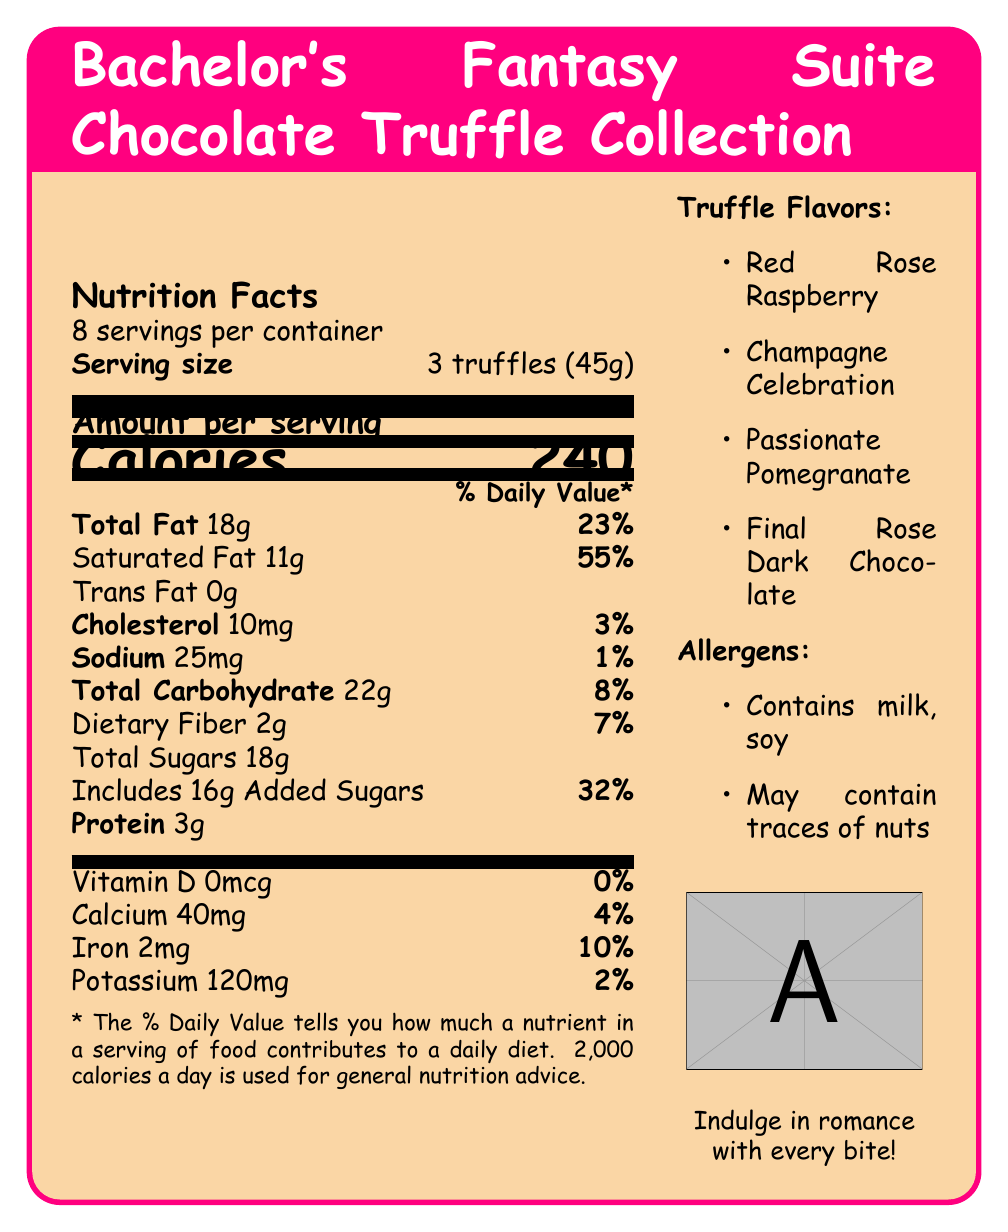which truffle flavor is not listed in the document? A. Red Rose Raspberry B. Champagne Celebration C. Sweet Strawberry D. Final Rose Dark Chocolate The truffle flavors listed are Red Rose Raspberry, Champagne Celebration, Passionate Pomegranate, and Final Rose Dark Chocolate. Sweet Strawberry is not listed.
Answer: C how many truffles make up one serving? According to the document, one serving size is 3 truffles (45g).
Answer: 3 truffles what are the total calories per serving? The document states that there are 240 calories per serving.
Answer: 240 calories which nutrient has the highest percentage daily value per serving? The \% Daily Value for Saturated Fat is 55\%, which is the highest among the listed nutrients.
Answer: Saturated Fat how many servings are in the container? The document specifies that there are 8 servings per container.
Answer: 8 servings which of the following is not an allergen mentioned in the document? A. Milk B. Soy C. Gluten D. Nuts The document lists milk and soy as allergens and mentions that it may contain traces of nuts. Gluten is not mentioned.
Answer: C does the document suggest pairing the truffles with Ben Higgins' Generous Coffee? The document includes Ben Higgins' Generous Coffee as one of the Bachelor-themed pairings.
Answer: Yes which vitamin or mineral has a daily value percentage of 0\%? The document lists Vitamin D with a daily value percentage of 0\%.
Answer: Vitamin D describe the main idea of the document in one sentence. The main idea is to present all the details about the Bachelor's Fantasy Suite Chocolate Truffle Collection, including nutrition, flavors, allergens, romantic and Bachelor-themed suggestions, and relevant podcast discussion topics.
Answer: The document provides nutritional information, flavors, allergens, and themed pairings for the Bachelor's Fantasy Suite Chocolate Truffle Collection, along with serving suggestions and podcast talking points. how much cholesterol is there per serving? The document mentions that each serving contains 10mg of cholesterol.
Answer: 10mg what percentage of the daily value for iron does one serving provide? The document lists the iron content as 2mg, which corresponds to 10\% of the daily value.
Answer: 10\% can be determined if these truffles are gluten-free based on the document? The document does not provide any information regarding the presence or absence of gluten.
Answer: Not enough information name one romantic serving suggestion given in the document. The document suggests various romantic serving suggestions, one of which is feeding each other truffles during a Fantasy Suite podcast recap.
Answer: Feed each other truffles during your Fantasy Suite podcast recap what are some of the podcast talking points provided in the document? These are some of the podcast talking points listed in the document.
Answer: Discuss which contestant would be most likely to indulge in these truffles, Debate whether these truffles would make it past TSA for hometown dates, Rate the truffle flavors based on iconic Bachelor moments, Create a Fantasy Suite Menu featuring these truffles as dessert 